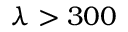<formula> <loc_0><loc_0><loc_500><loc_500>\lambda > 3 0 0</formula> 